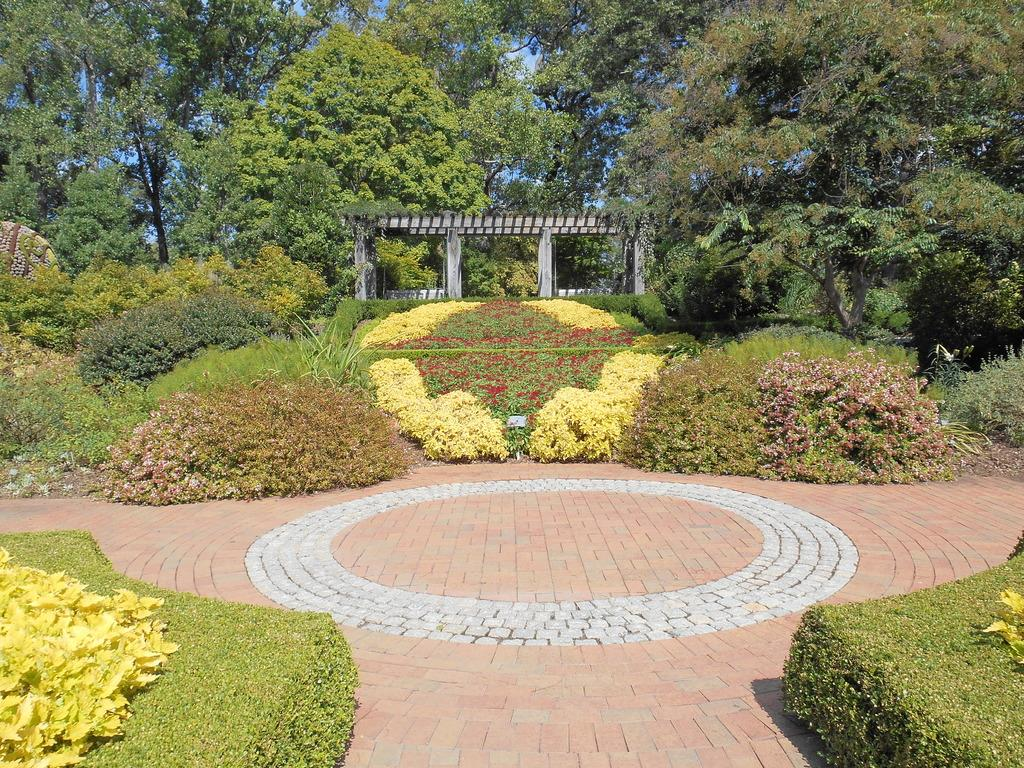What can be seen in the background of the image? In the background of the image, there are trees, the sky, and pillars. What is present in the front portion of the image? In the front portion of the image, there are bushes, plants, and the floor. Can you describe the vegetation in the image? The image features both trees and bushes, as well as plants in the front portion. What caused the rainstorm in the image? There is no rainstorm present in the image. What is the base of the pillars made of in the image? The provided facts do not mention the material or base of the pillars, so we cannot determine that information from the image. 